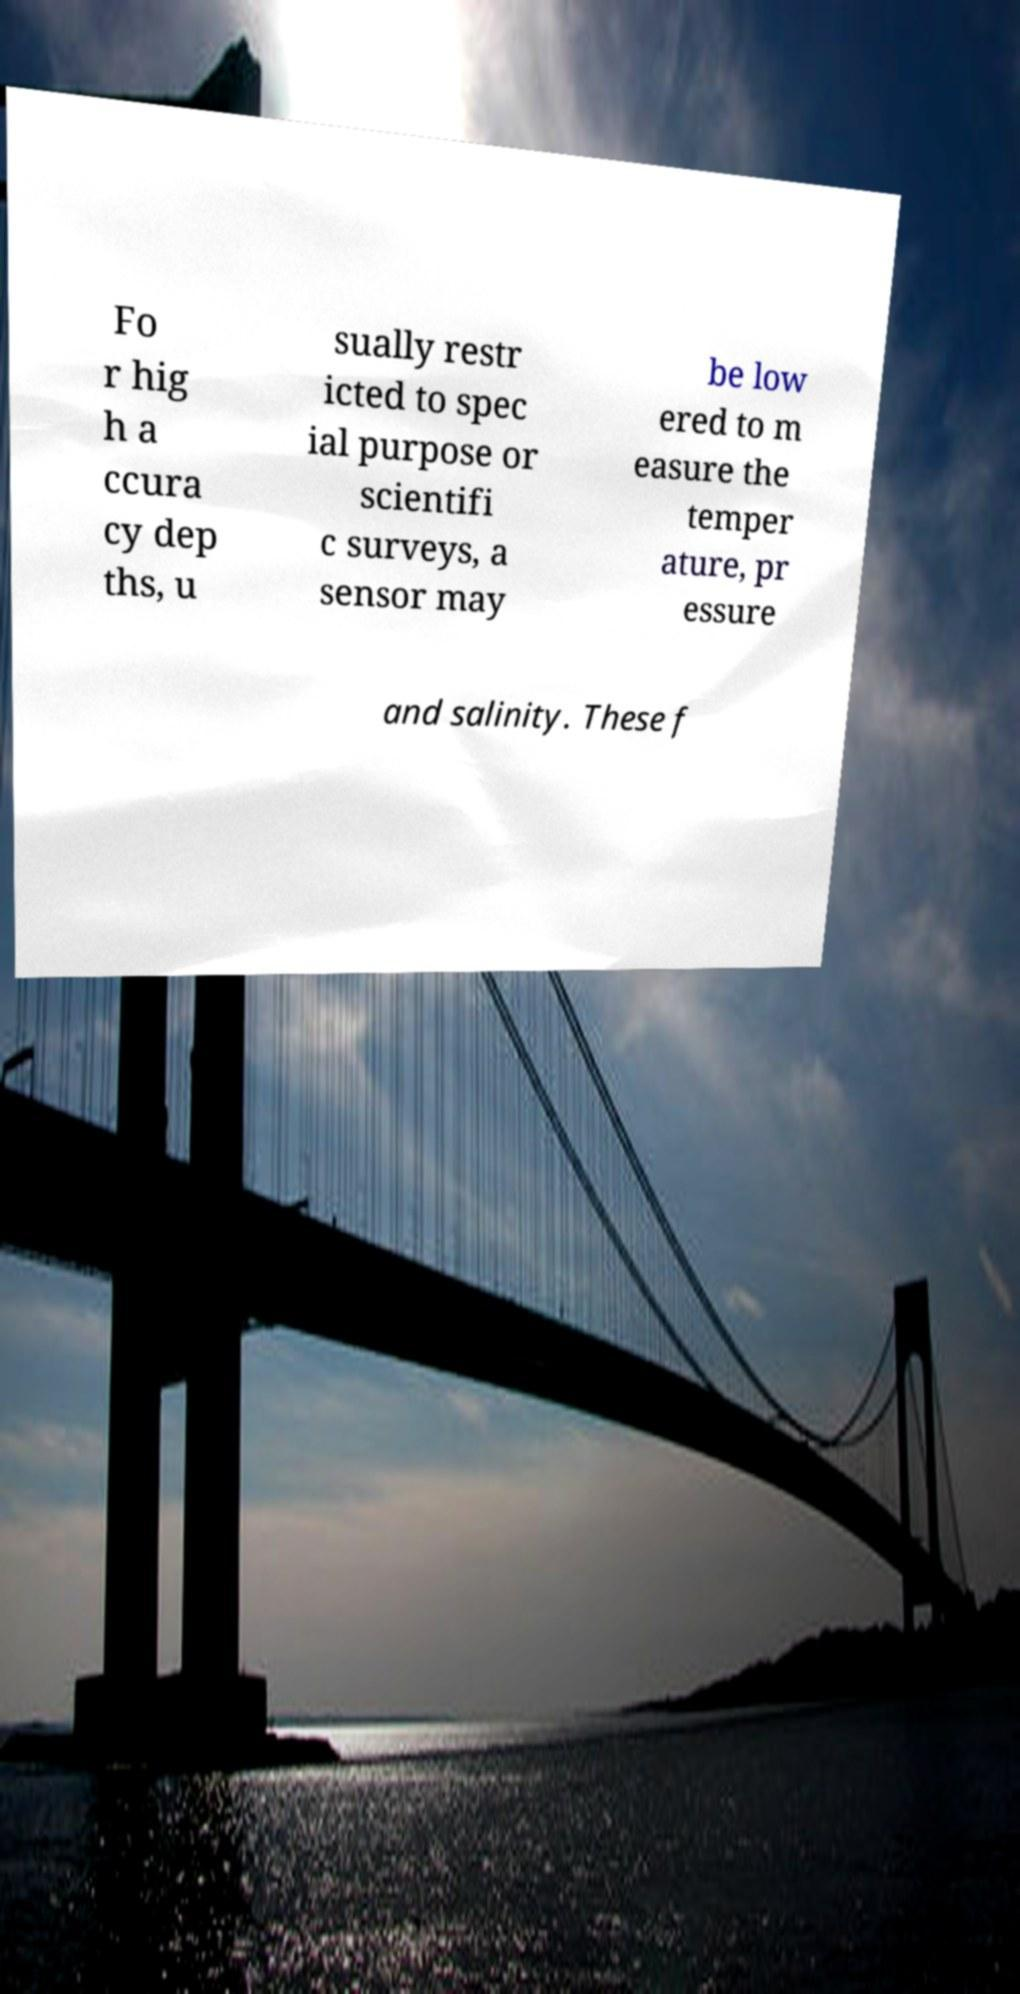I need the written content from this picture converted into text. Can you do that? Fo r hig h a ccura cy dep ths, u sually restr icted to spec ial purpose or scientifi c surveys, a sensor may be low ered to m easure the temper ature, pr essure and salinity. These f 